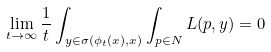<formula> <loc_0><loc_0><loc_500><loc_500>\lim _ { t \to \infty } \frac { 1 } { t } \int _ { y \in \sigma ( \phi _ { t } ( x ) , x ) } \int _ { p \in N } L ( p , y ) = 0</formula> 